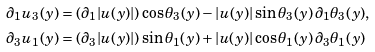Convert formula to latex. <formula><loc_0><loc_0><loc_500><loc_500>\partial _ { 1 } u _ { 3 } ( y ) & = ( \partial _ { 1 } | u ( y ) | ) \cos \theta _ { 3 } ( y ) - | u ( y ) | \sin \theta _ { 3 } ( y ) \, \partial _ { 1 } \theta _ { 3 } ( y ) , \\ \partial _ { 3 } u _ { 1 } ( y ) & = ( \partial _ { 3 } | u ( y ) | ) \sin \theta _ { 1 } ( y ) + | u ( y ) | \cos \theta _ { 1 } ( y ) \, \partial _ { 3 } \theta _ { 1 } ( y )</formula> 